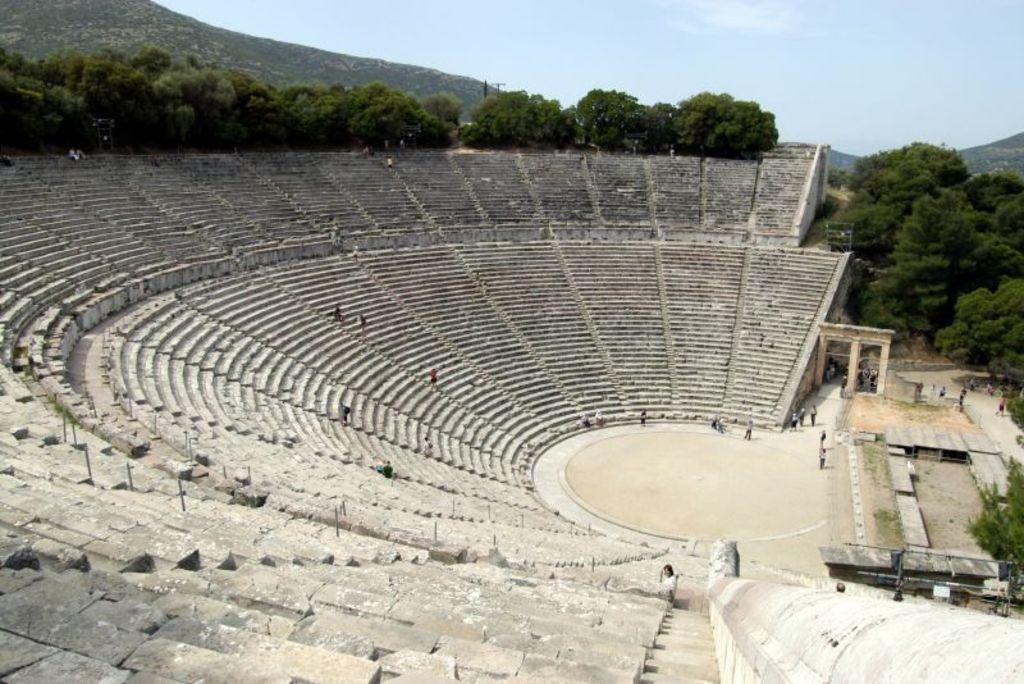What is the main subject of the image? There is an ancient theater of Epidaurus in the image. What type of natural elements can be seen in the image? There are trees visible in the image. What is visible at the top of the image? The sky is visible at the top of the image. How many ants can be seen crawling on the property in the image? There are no ants or property visible in the image; it features an ancient theater of Epidaurus. What type of currency is present in the image? There is no currency visible in the image. 